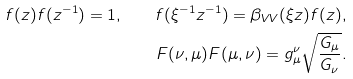<formula> <loc_0><loc_0><loc_500><loc_500>f ( z ) f ( z ^ { - 1 } ) = 1 , \quad f ( \xi ^ { - 1 } z ^ { - 1 } ) = \beta _ { V V } ( \xi z ) f ( z ) , \\ F ( \nu , \mu ) F ( \mu , \nu ) = g ^ { \nu } _ { \mu } \sqrt { \frac { G _ { \mu } } { G _ { \nu } } } .</formula> 